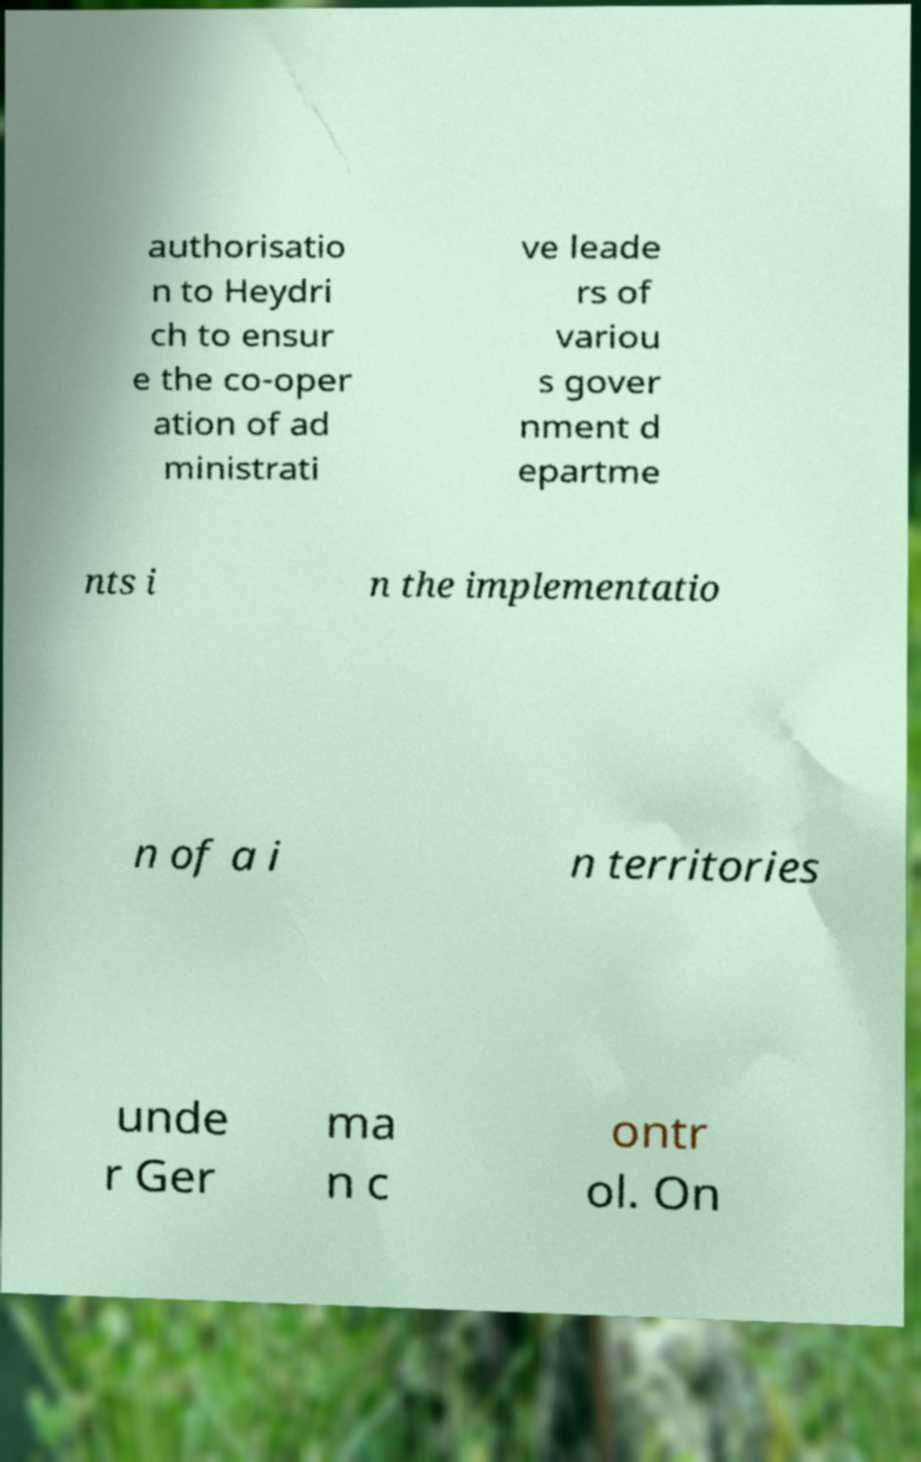Can you read and provide the text displayed in the image?This photo seems to have some interesting text. Can you extract and type it out for me? authorisatio n to Heydri ch to ensur e the co-oper ation of ad ministrati ve leade rs of variou s gover nment d epartme nts i n the implementatio n of a i n territories unde r Ger ma n c ontr ol. On 